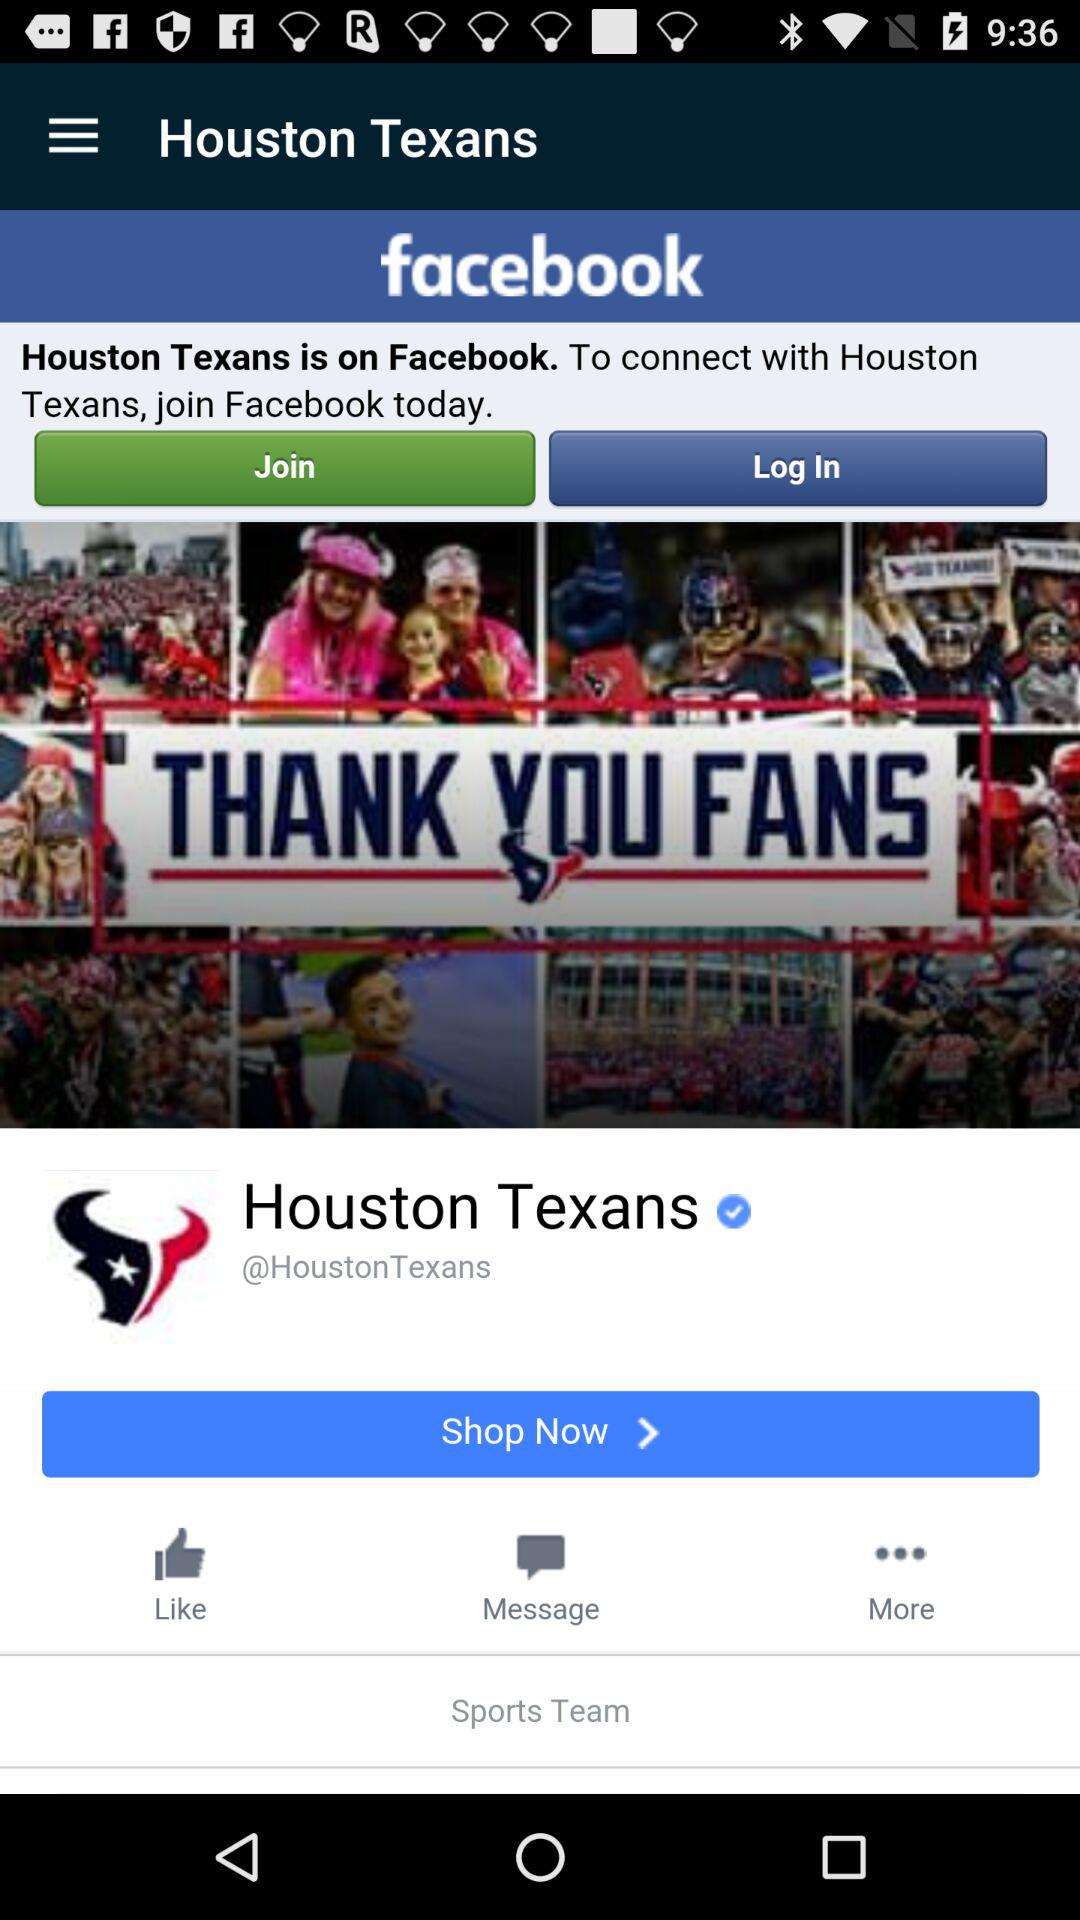What is the team name? The team name is "Houston Texans". 